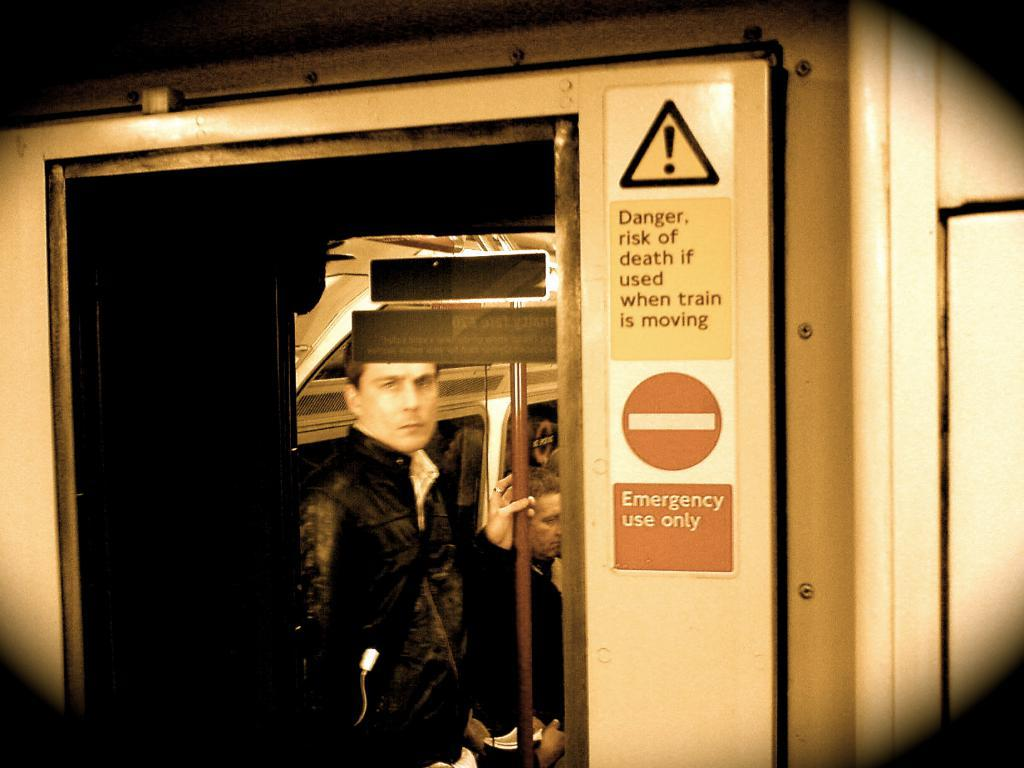Who is present in the image? There is a guy in the image. Where is the guy located? The guy is inside a metro train. What safety-related labels can be seen in the background of the image? There are danger and fire exit labels in the background of the image. What is the guy's tendency to jump in the image? There is no indication of the guy jumping or having a tendency to jump in the image. 